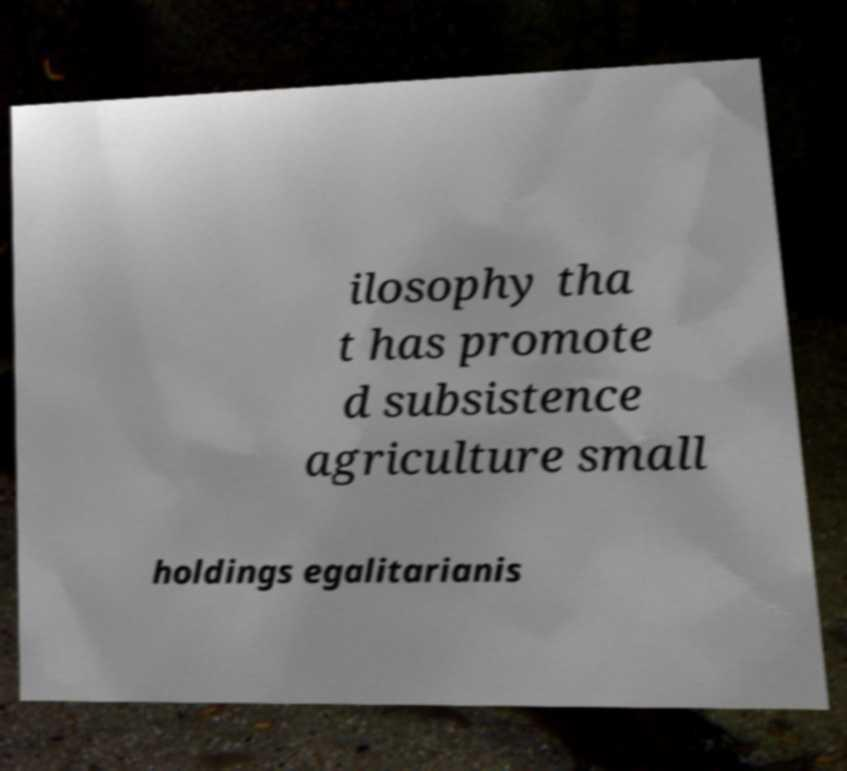Can you read and provide the text displayed in the image?This photo seems to have some interesting text. Can you extract and type it out for me? ilosophy tha t has promote d subsistence agriculture small holdings egalitarianis 